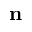<formula> <loc_0><loc_0><loc_500><loc_500>n</formula> 